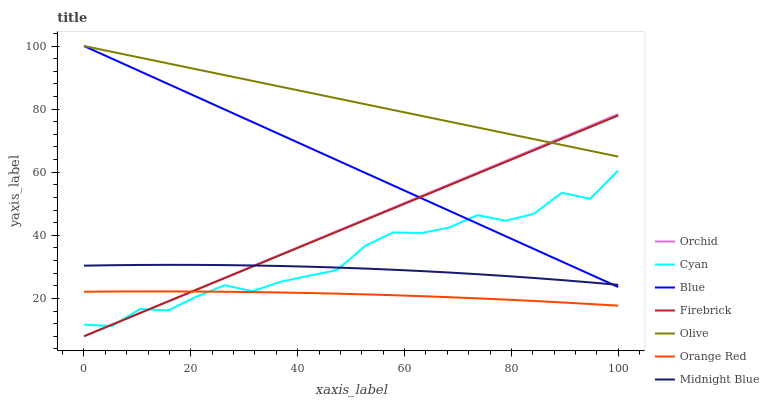Does Orange Red have the minimum area under the curve?
Answer yes or no. Yes. Does Olive have the maximum area under the curve?
Answer yes or no. Yes. Does Midnight Blue have the minimum area under the curve?
Answer yes or no. No. Does Midnight Blue have the maximum area under the curve?
Answer yes or no. No. Is Orchid the smoothest?
Answer yes or no. Yes. Is Cyan the roughest?
Answer yes or no. Yes. Is Midnight Blue the smoothest?
Answer yes or no. No. Is Midnight Blue the roughest?
Answer yes or no. No. Does Firebrick have the lowest value?
Answer yes or no. Yes. Does Midnight Blue have the lowest value?
Answer yes or no. No. Does Olive have the highest value?
Answer yes or no. Yes. Does Midnight Blue have the highest value?
Answer yes or no. No. Is Orange Red less than Blue?
Answer yes or no. Yes. Is Olive greater than Cyan?
Answer yes or no. Yes. Does Cyan intersect Orange Red?
Answer yes or no. Yes. Is Cyan less than Orange Red?
Answer yes or no. No. Is Cyan greater than Orange Red?
Answer yes or no. No. Does Orange Red intersect Blue?
Answer yes or no. No. 